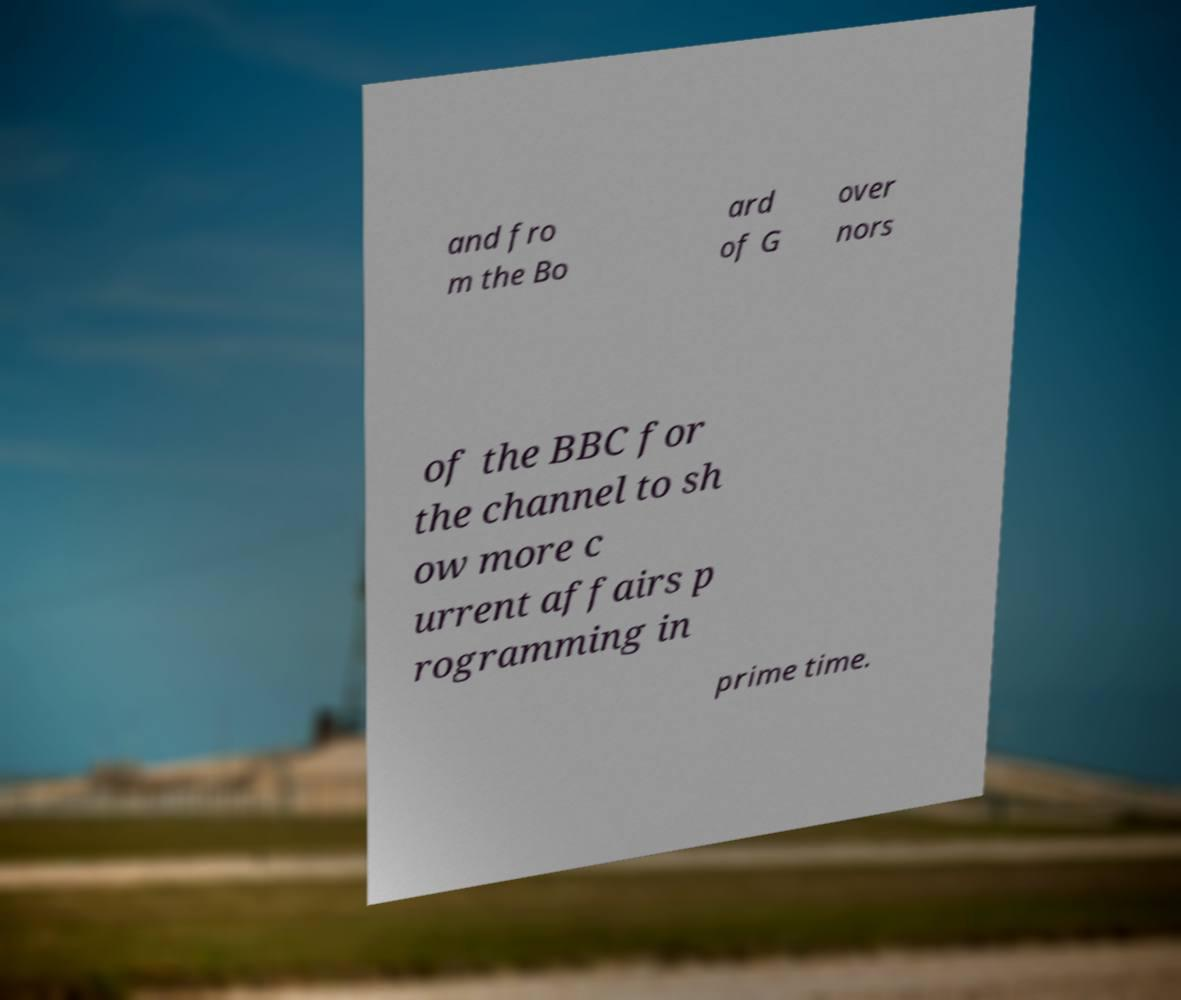For documentation purposes, I need the text within this image transcribed. Could you provide that? and fro m the Bo ard of G over nors of the BBC for the channel to sh ow more c urrent affairs p rogramming in prime time. 